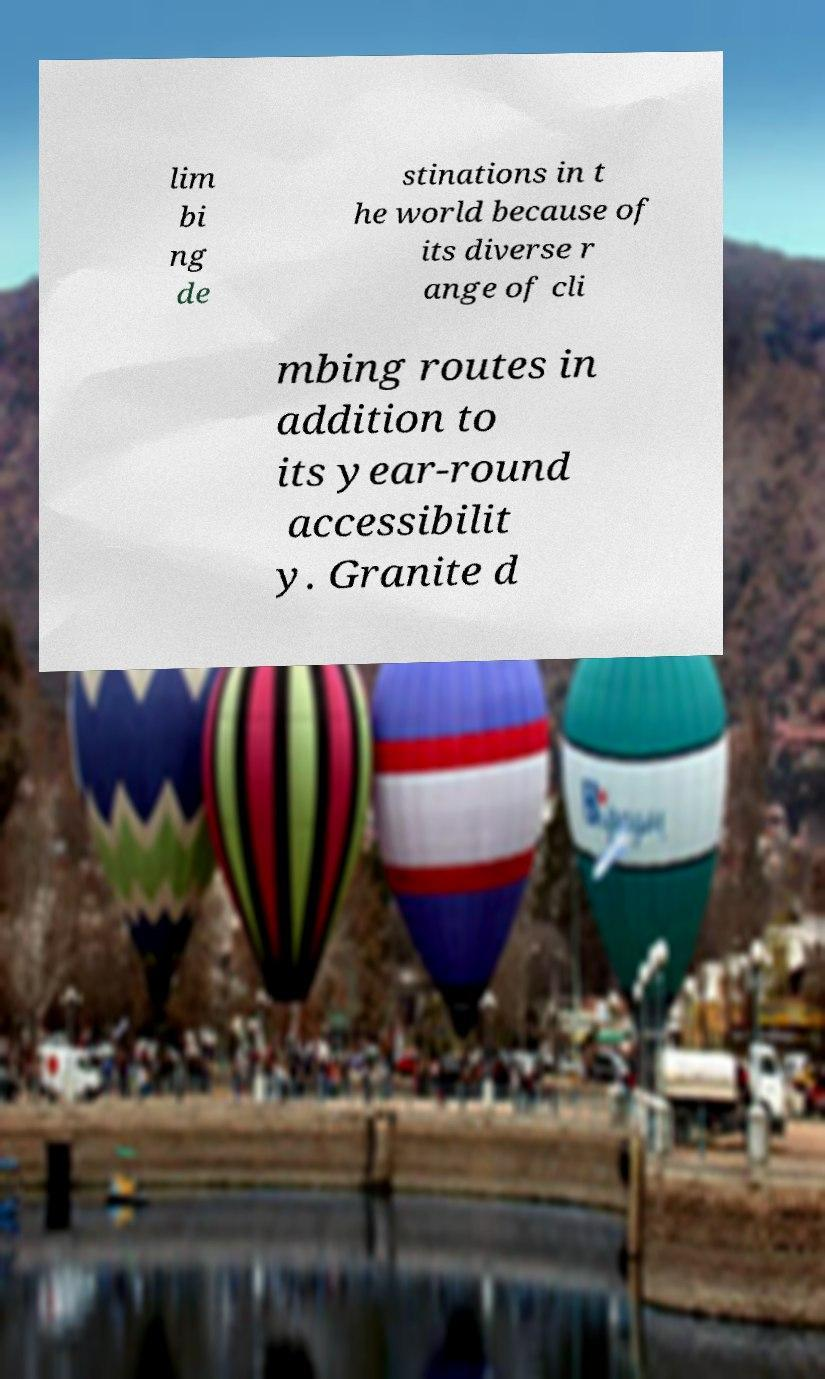Please identify and transcribe the text found in this image. lim bi ng de stinations in t he world because of its diverse r ange of cli mbing routes in addition to its year-round accessibilit y. Granite d 